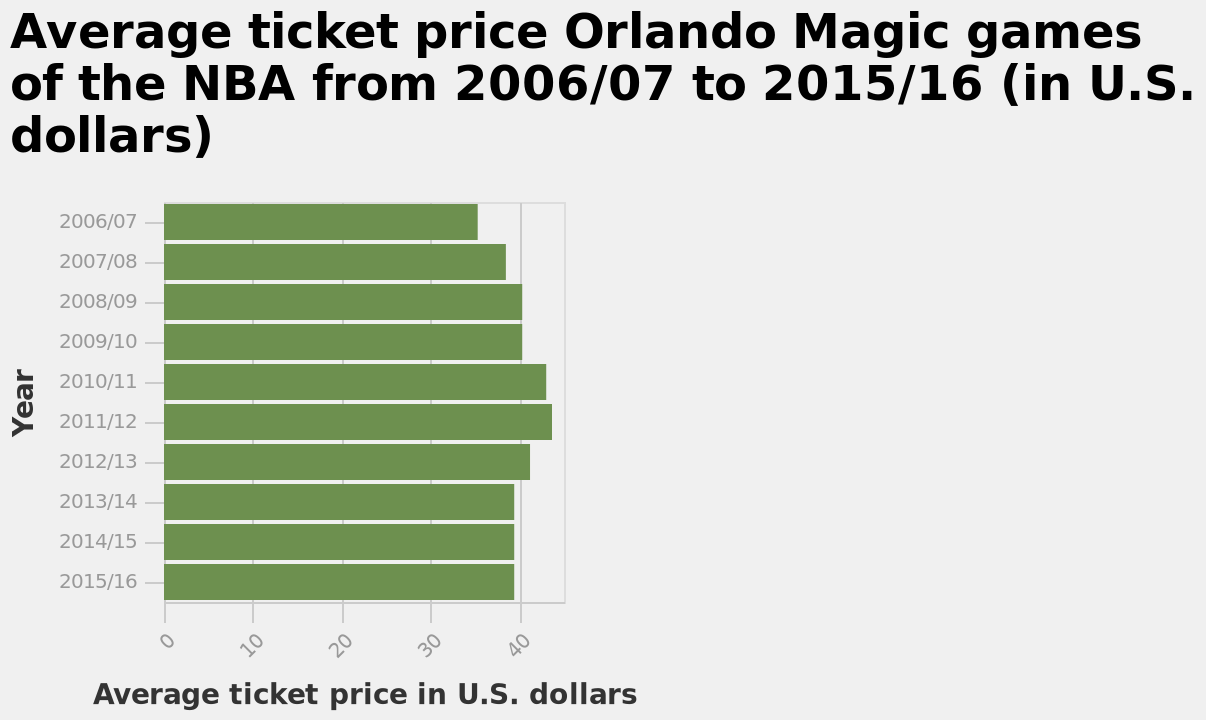<image>
What is displayed on the x-axis of the bar chart?  The x-axis of the bar chart measures the average ticket price in U.S. dollars. It uses a linear scale ranging from 0 to 40 to represent the prices. What was the lowest ticket price for an Orlando Magic NBA game in the 2006-07 season?  $35 What is the name of the bar chart and what does it represent?  The name of the bar chart is "Average ticket price Orlando Magic games of the NBA from 2006/07 to 2015/16 (in U.S. dollars)". It represents the average ticket prices for Orlando Magic games over a ten-year period. What was the ticket price for an Orlando Magic NBA game from the 2013-14 to the 2015-16 season? $39 